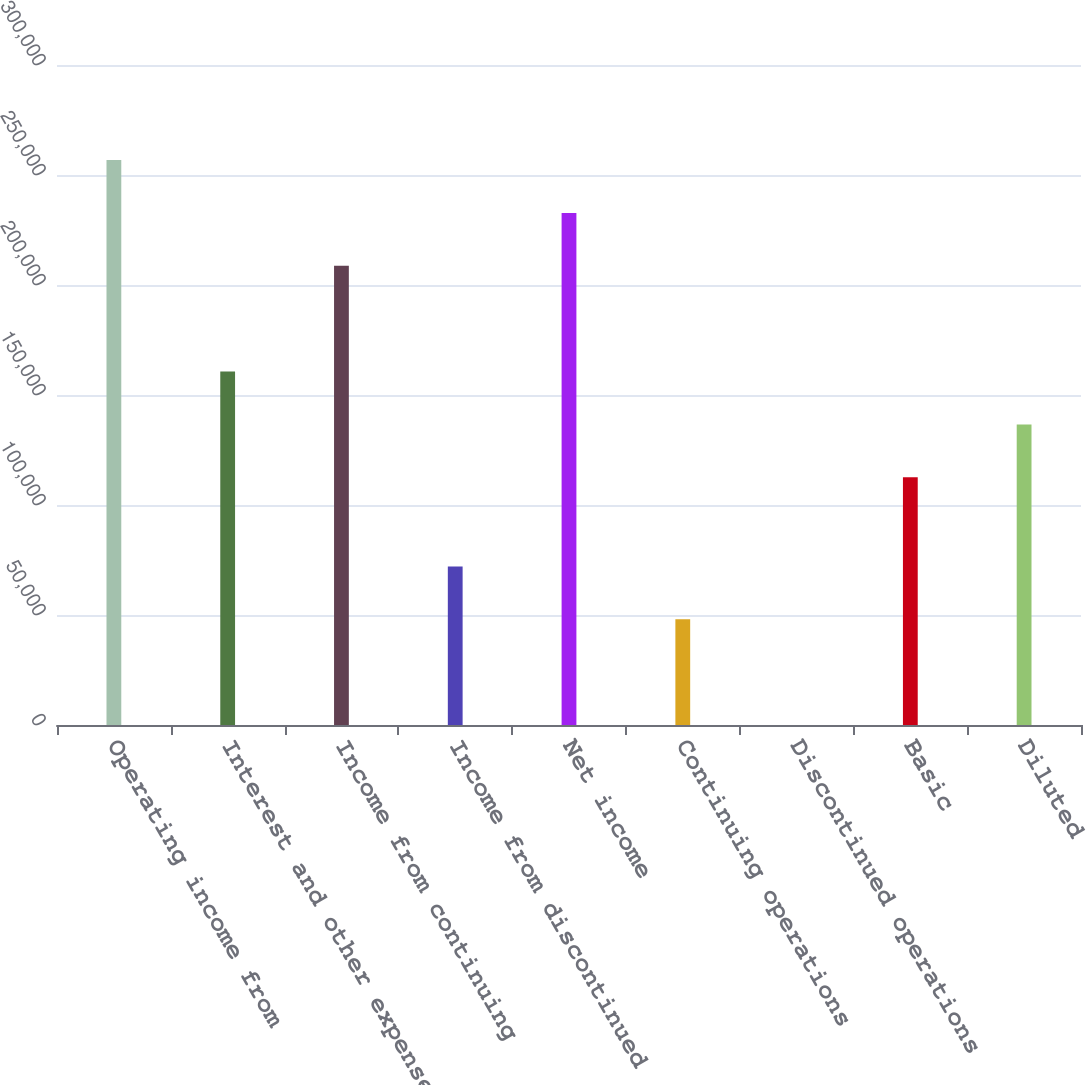<chart> <loc_0><loc_0><loc_500><loc_500><bar_chart><fcel>Operating income from<fcel>Interest and other expense net<fcel>Income from continuing<fcel>Income from discontinued<fcel>Net income<fcel>Continuing operations<fcel>Discontinued operations<fcel>Basic<fcel>Diluted<nl><fcel>256765<fcel>160650<fcel>208708<fcel>72086.3<fcel>232736<fcel>48057.6<fcel>0.25<fcel>112593<fcel>136622<nl></chart> 